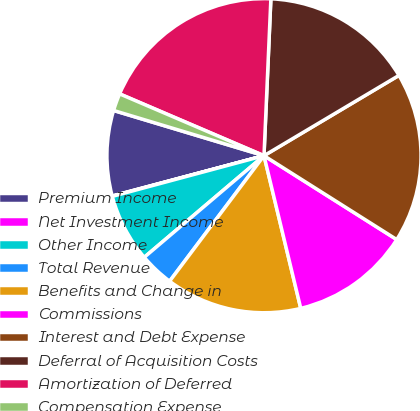Convert chart. <chart><loc_0><loc_0><loc_500><loc_500><pie_chart><fcel>Premium Income<fcel>Net Investment Income<fcel>Other Income<fcel>Total Revenue<fcel>Benefits and Change in<fcel>Commissions<fcel>Interest and Debt Expense<fcel>Deferral of Acquisition Costs<fcel>Amortization of Deferred<fcel>Compensation Expense<nl><fcel>8.78%<fcel>0.04%<fcel>7.03%<fcel>3.54%<fcel>14.02%<fcel>12.27%<fcel>17.51%<fcel>15.76%<fcel>19.26%<fcel>1.79%<nl></chart> 